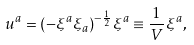Convert formula to latex. <formula><loc_0><loc_0><loc_500><loc_500>u ^ { a } = ( - \xi ^ { a } \xi _ { a } ) ^ { - \frac { 1 } { 2 } } \xi ^ { a } \equiv \frac { 1 } { V } \xi ^ { a } ,</formula> 